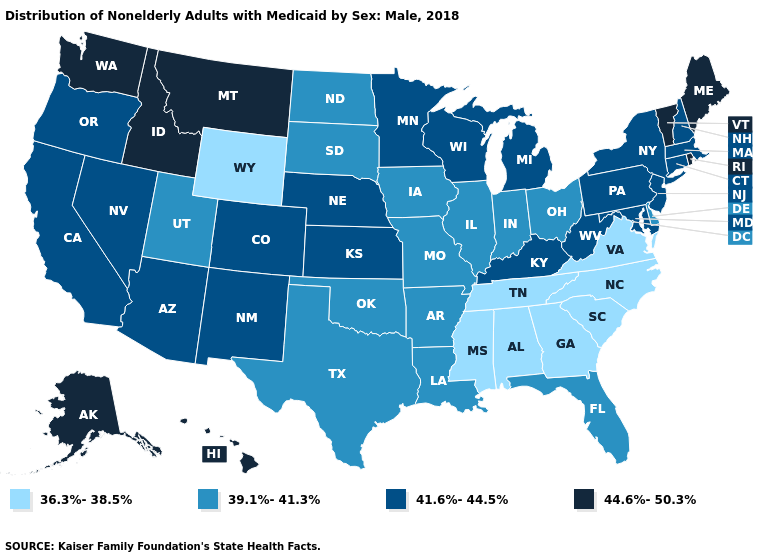Name the states that have a value in the range 44.6%-50.3%?
Give a very brief answer. Alaska, Hawaii, Idaho, Maine, Montana, Rhode Island, Vermont, Washington. Does Washington have the lowest value in the West?
Answer briefly. No. Name the states that have a value in the range 39.1%-41.3%?
Write a very short answer. Arkansas, Delaware, Florida, Illinois, Indiana, Iowa, Louisiana, Missouri, North Dakota, Ohio, Oklahoma, South Dakota, Texas, Utah. Does Ohio have the lowest value in the MidWest?
Answer briefly. Yes. What is the highest value in states that border Minnesota?
Quick response, please. 41.6%-44.5%. Does Massachusetts have a lower value than Minnesota?
Short answer required. No. Name the states that have a value in the range 44.6%-50.3%?
Keep it brief. Alaska, Hawaii, Idaho, Maine, Montana, Rhode Island, Vermont, Washington. Does the map have missing data?
Be succinct. No. What is the highest value in the USA?
Write a very short answer. 44.6%-50.3%. Name the states that have a value in the range 44.6%-50.3%?
Short answer required. Alaska, Hawaii, Idaho, Maine, Montana, Rhode Island, Vermont, Washington. What is the value of Maryland?
Concise answer only. 41.6%-44.5%. What is the value of Mississippi?
Quick response, please. 36.3%-38.5%. Does Colorado have a lower value than Hawaii?
Write a very short answer. Yes. Name the states that have a value in the range 39.1%-41.3%?
Answer briefly. Arkansas, Delaware, Florida, Illinois, Indiana, Iowa, Louisiana, Missouri, North Dakota, Ohio, Oklahoma, South Dakota, Texas, Utah. Name the states that have a value in the range 44.6%-50.3%?
Be succinct. Alaska, Hawaii, Idaho, Maine, Montana, Rhode Island, Vermont, Washington. 